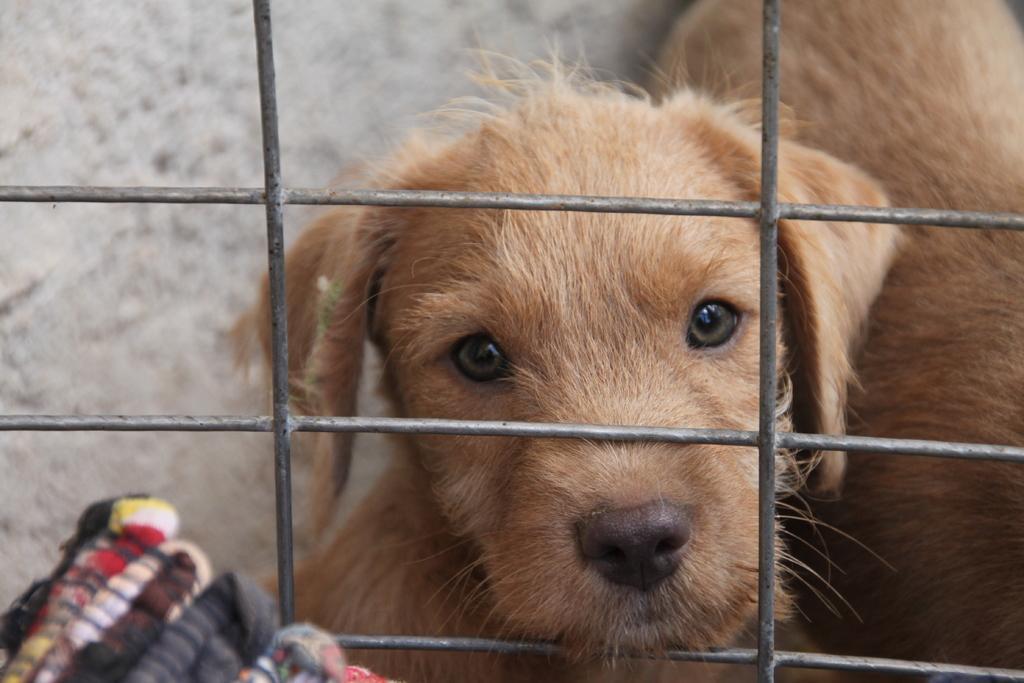Could you give a brief overview of what you see in this image? In this image I can see a dog in brown color in the cage. 